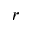Convert formula to latex. <formula><loc_0><loc_0><loc_500><loc_500>_ { r }</formula> 